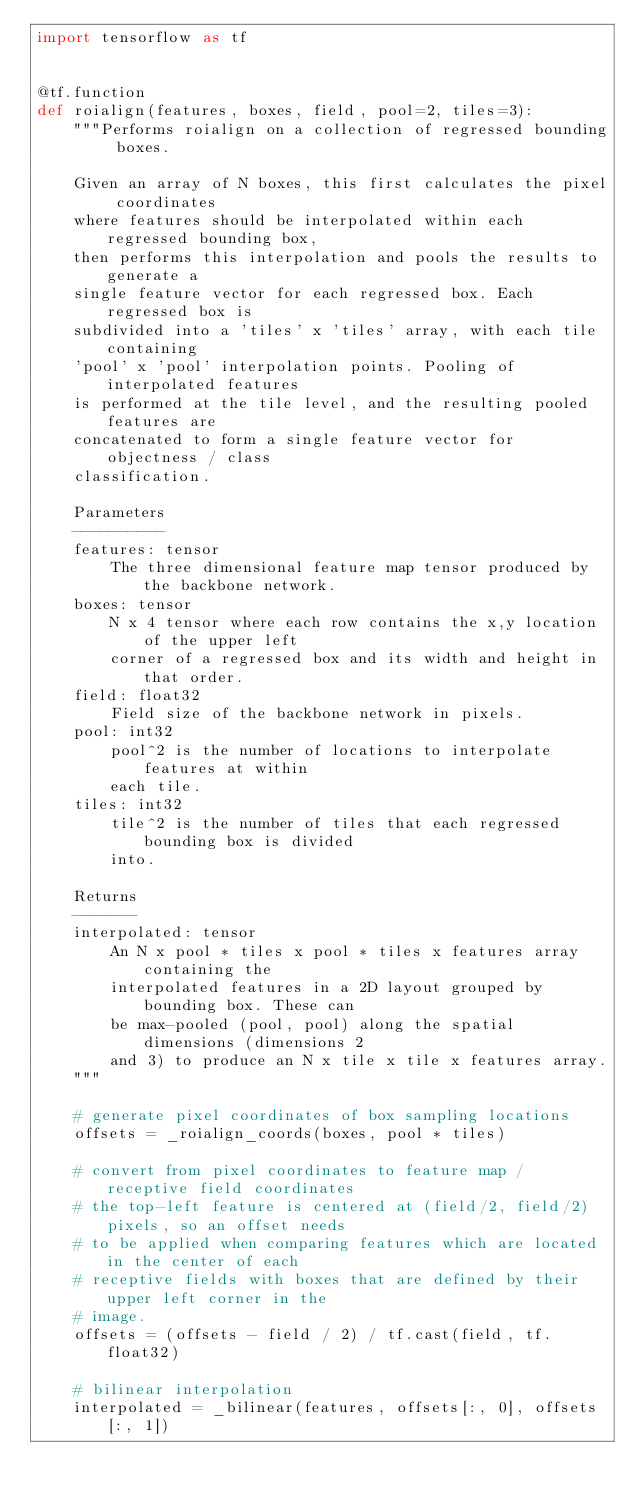Convert code to text. <code><loc_0><loc_0><loc_500><loc_500><_Python_>import tensorflow as tf


@tf.function
def roialign(features, boxes, field, pool=2, tiles=3):
    """Performs roialign on a collection of regressed bounding boxes.

    Given an array of N boxes, this first calculates the pixel coordinates
    where features should be interpolated within each regressed bounding box,
    then performs this interpolation and pools the results to generate a
    single feature vector for each regressed box. Each regressed box is
    subdivided into a 'tiles' x 'tiles' array, with each tile containing
    'pool' x 'pool' interpolation points. Pooling of interpolated features
    is performed at the tile level, and the resulting pooled features are
    concatenated to form a single feature vector for objectness / class
    classification.

    Parameters
    ----------
    features: tensor
        The three dimensional feature map tensor produced by the backbone network.
    boxes: tensor
        N x 4 tensor where each row contains the x,y location of the upper left
        corner of a regressed box and its width and height in that order.
    field: float32
        Field size of the backbone network in pixels.
    pool: int32
        pool^2 is the number of locations to interpolate features at within
        each tile.
    tiles: int32
        tile^2 is the number of tiles that each regressed bounding box is divided
        into.

    Returns
    -------
    interpolated: tensor
        An N x pool * tiles x pool * tiles x features array containing the
        interpolated features in a 2D layout grouped by bounding box. These can
        be max-pooled (pool, pool) along the spatial dimensions (dimensions 2
        and 3) to produce an N x tile x tile x features array.
    """

    # generate pixel coordinates of box sampling locations
    offsets = _roialign_coords(boxes, pool * tiles)

    # convert from pixel coordinates to feature map / receptive field coordinates
    # the top-left feature is centered at (field/2, field/2) pixels, so an offset needs
    # to be applied when comparing features which are located in the center of each
    # receptive fields with boxes that are defined by their upper left corner in the
    # image.
    offsets = (offsets - field / 2) / tf.cast(field, tf.float32)

    # bilinear interpolation
    interpolated = _bilinear(features, offsets[:, 0], offsets[:, 1])
</code> 